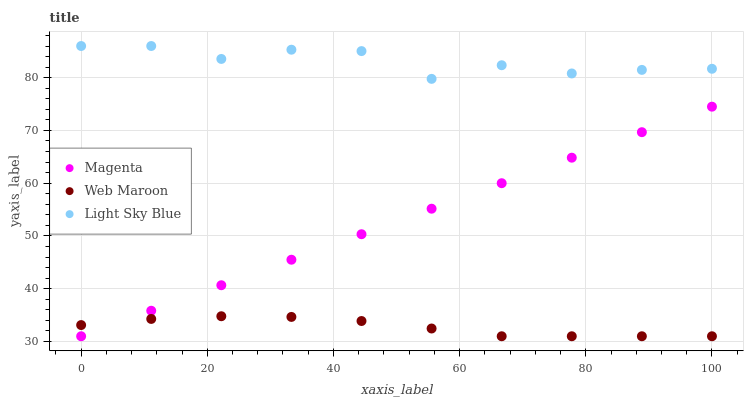Does Web Maroon have the minimum area under the curve?
Answer yes or no. Yes. Does Light Sky Blue have the maximum area under the curve?
Answer yes or no. Yes. Does Light Sky Blue have the minimum area under the curve?
Answer yes or no. No. Does Web Maroon have the maximum area under the curve?
Answer yes or no. No. Is Magenta the smoothest?
Answer yes or no. Yes. Is Light Sky Blue the roughest?
Answer yes or no. Yes. Is Web Maroon the smoothest?
Answer yes or no. No. Is Web Maroon the roughest?
Answer yes or no. No. Does Magenta have the lowest value?
Answer yes or no. Yes. Does Light Sky Blue have the lowest value?
Answer yes or no. No. Does Light Sky Blue have the highest value?
Answer yes or no. Yes. Does Web Maroon have the highest value?
Answer yes or no. No. Is Magenta less than Light Sky Blue?
Answer yes or no. Yes. Is Light Sky Blue greater than Magenta?
Answer yes or no. Yes. Does Web Maroon intersect Magenta?
Answer yes or no. Yes. Is Web Maroon less than Magenta?
Answer yes or no. No. Is Web Maroon greater than Magenta?
Answer yes or no. No. Does Magenta intersect Light Sky Blue?
Answer yes or no. No. 